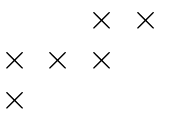<formula> <loc_0><loc_0><loc_500><loc_500>\begin{matrix} & & \times & \times \\ \times & \times & \times & \\ \times & & & \end{matrix}</formula> 